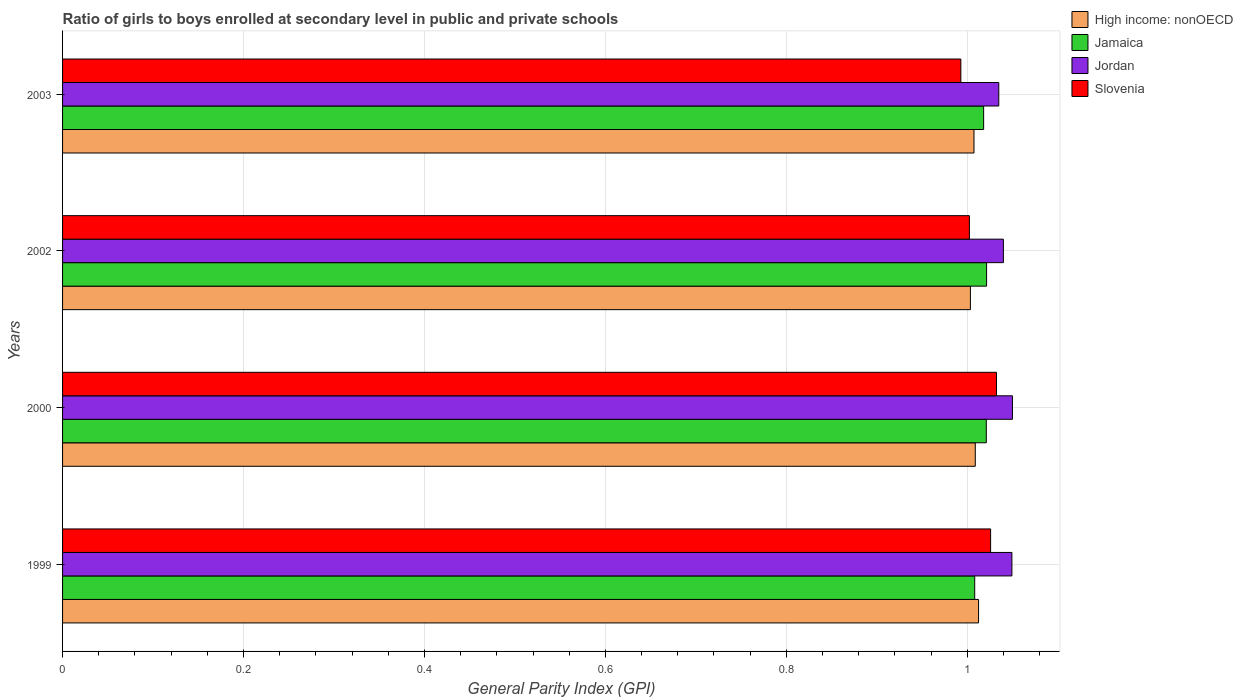How many bars are there on the 3rd tick from the top?
Your answer should be very brief. 4. What is the label of the 3rd group of bars from the top?
Make the answer very short. 2000. What is the general parity index in Slovenia in 1999?
Your answer should be compact. 1.03. Across all years, what is the maximum general parity index in Jamaica?
Ensure brevity in your answer.  1.02. Across all years, what is the minimum general parity index in Jordan?
Your answer should be very brief. 1.03. In which year was the general parity index in Jordan minimum?
Make the answer very short. 2003. What is the total general parity index in Slovenia in the graph?
Offer a very short reply. 4.05. What is the difference between the general parity index in Jamaica in 2002 and that in 2003?
Provide a succinct answer. 0. What is the difference between the general parity index in Jamaica in 1999 and the general parity index in High income: nonOECD in 2002?
Give a very brief answer. 0. What is the average general parity index in High income: nonOECD per year?
Give a very brief answer. 1.01. In the year 2000, what is the difference between the general parity index in High income: nonOECD and general parity index in Jamaica?
Offer a very short reply. -0.01. In how many years, is the general parity index in Jamaica greater than 0.7600000000000001 ?
Make the answer very short. 4. What is the ratio of the general parity index in Jordan in 1999 to that in 2000?
Your answer should be very brief. 1. Is the general parity index in Jordan in 1999 less than that in 2003?
Provide a succinct answer. No. What is the difference between the highest and the second highest general parity index in Jordan?
Provide a succinct answer. 0. What is the difference between the highest and the lowest general parity index in Slovenia?
Provide a succinct answer. 0.04. In how many years, is the general parity index in High income: nonOECD greater than the average general parity index in High income: nonOECD taken over all years?
Your answer should be very brief. 2. Is the sum of the general parity index in Jamaica in 1999 and 2000 greater than the maximum general parity index in High income: nonOECD across all years?
Provide a short and direct response. Yes. Is it the case that in every year, the sum of the general parity index in High income: nonOECD and general parity index in Slovenia is greater than the sum of general parity index in Jordan and general parity index in Jamaica?
Your response must be concise. No. What does the 4th bar from the top in 2002 represents?
Provide a short and direct response. High income: nonOECD. What does the 2nd bar from the bottom in 2002 represents?
Your answer should be compact. Jamaica. Is it the case that in every year, the sum of the general parity index in Jamaica and general parity index in Jordan is greater than the general parity index in High income: nonOECD?
Your answer should be very brief. Yes. Are all the bars in the graph horizontal?
Your answer should be very brief. Yes. How many years are there in the graph?
Give a very brief answer. 4. What is the difference between two consecutive major ticks on the X-axis?
Provide a succinct answer. 0.2. Are the values on the major ticks of X-axis written in scientific E-notation?
Your answer should be compact. No. Does the graph contain any zero values?
Provide a succinct answer. No. Does the graph contain grids?
Offer a very short reply. Yes. Where does the legend appear in the graph?
Offer a terse response. Top right. What is the title of the graph?
Your response must be concise. Ratio of girls to boys enrolled at secondary level in public and private schools. What is the label or title of the X-axis?
Your response must be concise. General Parity Index (GPI). What is the label or title of the Y-axis?
Offer a terse response. Years. What is the General Parity Index (GPI) of High income: nonOECD in 1999?
Offer a very short reply. 1.01. What is the General Parity Index (GPI) in Jamaica in 1999?
Offer a terse response. 1.01. What is the General Parity Index (GPI) of Jordan in 1999?
Keep it short and to the point. 1.05. What is the General Parity Index (GPI) in Slovenia in 1999?
Your answer should be compact. 1.03. What is the General Parity Index (GPI) of High income: nonOECD in 2000?
Provide a succinct answer. 1.01. What is the General Parity Index (GPI) of Jamaica in 2000?
Offer a terse response. 1.02. What is the General Parity Index (GPI) in Jordan in 2000?
Give a very brief answer. 1.05. What is the General Parity Index (GPI) in Slovenia in 2000?
Your answer should be compact. 1.03. What is the General Parity Index (GPI) of High income: nonOECD in 2002?
Your answer should be very brief. 1. What is the General Parity Index (GPI) in Jamaica in 2002?
Your response must be concise. 1.02. What is the General Parity Index (GPI) in Jordan in 2002?
Provide a short and direct response. 1.04. What is the General Parity Index (GPI) of Slovenia in 2002?
Provide a succinct answer. 1. What is the General Parity Index (GPI) of High income: nonOECD in 2003?
Offer a terse response. 1.01. What is the General Parity Index (GPI) of Jamaica in 2003?
Keep it short and to the point. 1.02. What is the General Parity Index (GPI) of Jordan in 2003?
Offer a terse response. 1.03. What is the General Parity Index (GPI) in Slovenia in 2003?
Your answer should be very brief. 0.99. Across all years, what is the maximum General Parity Index (GPI) of High income: nonOECD?
Your response must be concise. 1.01. Across all years, what is the maximum General Parity Index (GPI) of Jamaica?
Offer a terse response. 1.02. Across all years, what is the maximum General Parity Index (GPI) of Jordan?
Keep it short and to the point. 1.05. Across all years, what is the maximum General Parity Index (GPI) in Slovenia?
Your answer should be very brief. 1.03. Across all years, what is the minimum General Parity Index (GPI) in High income: nonOECD?
Provide a succinct answer. 1. Across all years, what is the minimum General Parity Index (GPI) in Jamaica?
Your response must be concise. 1.01. Across all years, what is the minimum General Parity Index (GPI) in Jordan?
Offer a terse response. 1.03. Across all years, what is the minimum General Parity Index (GPI) in Slovenia?
Provide a short and direct response. 0.99. What is the total General Parity Index (GPI) in High income: nonOECD in the graph?
Offer a very short reply. 4.03. What is the total General Parity Index (GPI) of Jamaica in the graph?
Keep it short and to the point. 4.07. What is the total General Parity Index (GPI) in Jordan in the graph?
Your answer should be compact. 4.17. What is the total General Parity Index (GPI) in Slovenia in the graph?
Your answer should be very brief. 4.05. What is the difference between the General Parity Index (GPI) of High income: nonOECD in 1999 and that in 2000?
Your answer should be very brief. 0. What is the difference between the General Parity Index (GPI) in Jamaica in 1999 and that in 2000?
Your response must be concise. -0.01. What is the difference between the General Parity Index (GPI) in Jordan in 1999 and that in 2000?
Your response must be concise. -0. What is the difference between the General Parity Index (GPI) of Slovenia in 1999 and that in 2000?
Make the answer very short. -0.01. What is the difference between the General Parity Index (GPI) of High income: nonOECD in 1999 and that in 2002?
Give a very brief answer. 0.01. What is the difference between the General Parity Index (GPI) of Jamaica in 1999 and that in 2002?
Offer a terse response. -0.01. What is the difference between the General Parity Index (GPI) in Jordan in 1999 and that in 2002?
Your answer should be very brief. 0.01. What is the difference between the General Parity Index (GPI) of Slovenia in 1999 and that in 2002?
Provide a succinct answer. 0.02. What is the difference between the General Parity Index (GPI) of High income: nonOECD in 1999 and that in 2003?
Offer a very short reply. 0.01. What is the difference between the General Parity Index (GPI) in Jamaica in 1999 and that in 2003?
Your answer should be very brief. -0.01. What is the difference between the General Parity Index (GPI) in Jordan in 1999 and that in 2003?
Your response must be concise. 0.01. What is the difference between the General Parity Index (GPI) in Slovenia in 1999 and that in 2003?
Keep it short and to the point. 0.03. What is the difference between the General Parity Index (GPI) in High income: nonOECD in 2000 and that in 2002?
Give a very brief answer. 0.01. What is the difference between the General Parity Index (GPI) of Jamaica in 2000 and that in 2002?
Make the answer very short. -0. What is the difference between the General Parity Index (GPI) of Jordan in 2000 and that in 2002?
Your response must be concise. 0.01. What is the difference between the General Parity Index (GPI) in High income: nonOECD in 2000 and that in 2003?
Your answer should be very brief. 0. What is the difference between the General Parity Index (GPI) in Jamaica in 2000 and that in 2003?
Keep it short and to the point. 0. What is the difference between the General Parity Index (GPI) in Jordan in 2000 and that in 2003?
Keep it short and to the point. 0.02. What is the difference between the General Parity Index (GPI) in Slovenia in 2000 and that in 2003?
Offer a very short reply. 0.04. What is the difference between the General Parity Index (GPI) of High income: nonOECD in 2002 and that in 2003?
Your answer should be very brief. -0. What is the difference between the General Parity Index (GPI) in Jamaica in 2002 and that in 2003?
Your answer should be compact. 0. What is the difference between the General Parity Index (GPI) of Jordan in 2002 and that in 2003?
Keep it short and to the point. 0.01. What is the difference between the General Parity Index (GPI) in Slovenia in 2002 and that in 2003?
Offer a terse response. 0.01. What is the difference between the General Parity Index (GPI) of High income: nonOECD in 1999 and the General Parity Index (GPI) of Jamaica in 2000?
Your answer should be very brief. -0.01. What is the difference between the General Parity Index (GPI) of High income: nonOECD in 1999 and the General Parity Index (GPI) of Jordan in 2000?
Your answer should be very brief. -0.04. What is the difference between the General Parity Index (GPI) of High income: nonOECD in 1999 and the General Parity Index (GPI) of Slovenia in 2000?
Your answer should be very brief. -0.02. What is the difference between the General Parity Index (GPI) in Jamaica in 1999 and the General Parity Index (GPI) in Jordan in 2000?
Keep it short and to the point. -0.04. What is the difference between the General Parity Index (GPI) in Jamaica in 1999 and the General Parity Index (GPI) in Slovenia in 2000?
Your answer should be very brief. -0.02. What is the difference between the General Parity Index (GPI) of Jordan in 1999 and the General Parity Index (GPI) of Slovenia in 2000?
Offer a terse response. 0.02. What is the difference between the General Parity Index (GPI) of High income: nonOECD in 1999 and the General Parity Index (GPI) of Jamaica in 2002?
Offer a very short reply. -0.01. What is the difference between the General Parity Index (GPI) in High income: nonOECD in 1999 and the General Parity Index (GPI) in Jordan in 2002?
Offer a terse response. -0.03. What is the difference between the General Parity Index (GPI) in High income: nonOECD in 1999 and the General Parity Index (GPI) in Slovenia in 2002?
Offer a very short reply. 0.01. What is the difference between the General Parity Index (GPI) of Jamaica in 1999 and the General Parity Index (GPI) of Jordan in 2002?
Offer a terse response. -0.03. What is the difference between the General Parity Index (GPI) of Jamaica in 1999 and the General Parity Index (GPI) of Slovenia in 2002?
Keep it short and to the point. 0.01. What is the difference between the General Parity Index (GPI) in Jordan in 1999 and the General Parity Index (GPI) in Slovenia in 2002?
Your answer should be compact. 0.05. What is the difference between the General Parity Index (GPI) in High income: nonOECD in 1999 and the General Parity Index (GPI) in Jamaica in 2003?
Keep it short and to the point. -0.01. What is the difference between the General Parity Index (GPI) of High income: nonOECD in 1999 and the General Parity Index (GPI) of Jordan in 2003?
Your answer should be very brief. -0.02. What is the difference between the General Parity Index (GPI) in High income: nonOECD in 1999 and the General Parity Index (GPI) in Slovenia in 2003?
Your answer should be very brief. 0.02. What is the difference between the General Parity Index (GPI) of Jamaica in 1999 and the General Parity Index (GPI) of Jordan in 2003?
Your response must be concise. -0.03. What is the difference between the General Parity Index (GPI) in Jamaica in 1999 and the General Parity Index (GPI) in Slovenia in 2003?
Your answer should be compact. 0.02. What is the difference between the General Parity Index (GPI) of Jordan in 1999 and the General Parity Index (GPI) of Slovenia in 2003?
Your answer should be very brief. 0.06. What is the difference between the General Parity Index (GPI) in High income: nonOECD in 2000 and the General Parity Index (GPI) in Jamaica in 2002?
Offer a terse response. -0.01. What is the difference between the General Parity Index (GPI) of High income: nonOECD in 2000 and the General Parity Index (GPI) of Jordan in 2002?
Your response must be concise. -0.03. What is the difference between the General Parity Index (GPI) in High income: nonOECD in 2000 and the General Parity Index (GPI) in Slovenia in 2002?
Your answer should be compact. 0.01. What is the difference between the General Parity Index (GPI) in Jamaica in 2000 and the General Parity Index (GPI) in Jordan in 2002?
Your answer should be compact. -0.02. What is the difference between the General Parity Index (GPI) in Jamaica in 2000 and the General Parity Index (GPI) in Slovenia in 2002?
Your answer should be compact. 0.02. What is the difference between the General Parity Index (GPI) of Jordan in 2000 and the General Parity Index (GPI) of Slovenia in 2002?
Ensure brevity in your answer.  0.05. What is the difference between the General Parity Index (GPI) in High income: nonOECD in 2000 and the General Parity Index (GPI) in Jamaica in 2003?
Offer a terse response. -0.01. What is the difference between the General Parity Index (GPI) of High income: nonOECD in 2000 and the General Parity Index (GPI) of Jordan in 2003?
Provide a succinct answer. -0.03. What is the difference between the General Parity Index (GPI) in High income: nonOECD in 2000 and the General Parity Index (GPI) in Slovenia in 2003?
Make the answer very short. 0.02. What is the difference between the General Parity Index (GPI) of Jamaica in 2000 and the General Parity Index (GPI) of Jordan in 2003?
Your answer should be very brief. -0.01. What is the difference between the General Parity Index (GPI) of Jamaica in 2000 and the General Parity Index (GPI) of Slovenia in 2003?
Provide a succinct answer. 0.03. What is the difference between the General Parity Index (GPI) in Jordan in 2000 and the General Parity Index (GPI) in Slovenia in 2003?
Your answer should be compact. 0.06. What is the difference between the General Parity Index (GPI) in High income: nonOECD in 2002 and the General Parity Index (GPI) in Jamaica in 2003?
Provide a succinct answer. -0.01. What is the difference between the General Parity Index (GPI) in High income: nonOECD in 2002 and the General Parity Index (GPI) in Jordan in 2003?
Your answer should be compact. -0.03. What is the difference between the General Parity Index (GPI) in High income: nonOECD in 2002 and the General Parity Index (GPI) in Slovenia in 2003?
Provide a short and direct response. 0.01. What is the difference between the General Parity Index (GPI) in Jamaica in 2002 and the General Parity Index (GPI) in Jordan in 2003?
Ensure brevity in your answer.  -0.01. What is the difference between the General Parity Index (GPI) of Jamaica in 2002 and the General Parity Index (GPI) of Slovenia in 2003?
Keep it short and to the point. 0.03. What is the difference between the General Parity Index (GPI) of Jordan in 2002 and the General Parity Index (GPI) of Slovenia in 2003?
Your answer should be very brief. 0.05. What is the average General Parity Index (GPI) in Jamaica per year?
Your response must be concise. 1.02. What is the average General Parity Index (GPI) in Jordan per year?
Offer a terse response. 1.04. What is the average General Parity Index (GPI) in Slovenia per year?
Provide a short and direct response. 1.01. In the year 1999, what is the difference between the General Parity Index (GPI) in High income: nonOECD and General Parity Index (GPI) in Jamaica?
Give a very brief answer. 0. In the year 1999, what is the difference between the General Parity Index (GPI) in High income: nonOECD and General Parity Index (GPI) in Jordan?
Offer a very short reply. -0.04. In the year 1999, what is the difference between the General Parity Index (GPI) in High income: nonOECD and General Parity Index (GPI) in Slovenia?
Provide a succinct answer. -0.01. In the year 1999, what is the difference between the General Parity Index (GPI) of Jamaica and General Parity Index (GPI) of Jordan?
Ensure brevity in your answer.  -0.04. In the year 1999, what is the difference between the General Parity Index (GPI) in Jamaica and General Parity Index (GPI) in Slovenia?
Your response must be concise. -0.02. In the year 1999, what is the difference between the General Parity Index (GPI) of Jordan and General Parity Index (GPI) of Slovenia?
Keep it short and to the point. 0.02. In the year 2000, what is the difference between the General Parity Index (GPI) of High income: nonOECD and General Parity Index (GPI) of Jamaica?
Your answer should be compact. -0.01. In the year 2000, what is the difference between the General Parity Index (GPI) of High income: nonOECD and General Parity Index (GPI) of Jordan?
Give a very brief answer. -0.04. In the year 2000, what is the difference between the General Parity Index (GPI) of High income: nonOECD and General Parity Index (GPI) of Slovenia?
Provide a short and direct response. -0.02. In the year 2000, what is the difference between the General Parity Index (GPI) in Jamaica and General Parity Index (GPI) in Jordan?
Your answer should be compact. -0.03. In the year 2000, what is the difference between the General Parity Index (GPI) in Jamaica and General Parity Index (GPI) in Slovenia?
Give a very brief answer. -0.01. In the year 2000, what is the difference between the General Parity Index (GPI) of Jordan and General Parity Index (GPI) of Slovenia?
Offer a terse response. 0.02. In the year 2002, what is the difference between the General Parity Index (GPI) of High income: nonOECD and General Parity Index (GPI) of Jamaica?
Ensure brevity in your answer.  -0.02. In the year 2002, what is the difference between the General Parity Index (GPI) in High income: nonOECD and General Parity Index (GPI) in Jordan?
Your response must be concise. -0.04. In the year 2002, what is the difference between the General Parity Index (GPI) of High income: nonOECD and General Parity Index (GPI) of Slovenia?
Your answer should be compact. 0. In the year 2002, what is the difference between the General Parity Index (GPI) of Jamaica and General Parity Index (GPI) of Jordan?
Provide a succinct answer. -0.02. In the year 2002, what is the difference between the General Parity Index (GPI) of Jamaica and General Parity Index (GPI) of Slovenia?
Keep it short and to the point. 0.02. In the year 2002, what is the difference between the General Parity Index (GPI) in Jordan and General Parity Index (GPI) in Slovenia?
Offer a very short reply. 0.04. In the year 2003, what is the difference between the General Parity Index (GPI) of High income: nonOECD and General Parity Index (GPI) of Jamaica?
Your answer should be very brief. -0.01. In the year 2003, what is the difference between the General Parity Index (GPI) of High income: nonOECD and General Parity Index (GPI) of Jordan?
Provide a succinct answer. -0.03. In the year 2003, what is the difference between the General Parity Index (GPI) in High income: nonOECD and General Parity Index (GPI) in Slovenia?
Keep it short and to the point. 0.01. In the year 2003, what is the difference between the General Parity Index (GPI) of Jamaica and General Parity Index (GPI) of Jordan?
Provide a short and direct response. -0.02. In the year 2003, what is the difference between the General Parity Index (GPI) of Jamaica and General Parity Index (GPI) of Slovenia?
Give a very brief answer. 0.03. In the year 2003, what is the difference between the General Parity Index (GPI) of Jordan and General Parity Index (GPI) of Slovenia?
Provide a short and direct response. 0.04. What is the ratio of the General Parity Index (GPI) in Jamaica in 1999 to that in 2000?
Offer a terse response. 0.99. What is the ratio of the General Parity Index (GPI) in High income: nonOECD in 1999 to that in 2002?
Make the answer very short. 1.01. What is the ratio of the General Parity Index (GPI) in Jamaica in 1999 to that in 2002?
Your response must be concise. 0.99. What is the ratio of the General Parity Index (GPI) in Jordan in 1999 to that in 2002?
Provide a short and direct response. 1.01. What is the ratio of the General Parity Index (GPI) in Slovenia in 1999 to that in 2002?
Keep it short and to the point. 1.02. What is the ratio of the General Parity Index (GPI) of High income: nonOECD in 1999 to that in 2003?
Your answer should be very brief. 1. What is the ratio of the General Parity Index (GPI) of Jamaica in 1999 to that in 2003?
Your response must be concise. 0.99. What is the ratio of the General Parity Index (GPI) of Jordan in 1999 to that in 2003?
Make the answer very short. 1.01. What is the ratio of the General Parity Index (GPI) in Slovenia in 1999 to that in 2003?
Give a very brief answer. 1.03. What is the ratio of the General Parity Index (GPI) of High income: nonOECD in 2000 to that in 2002?
Offer a very short reply. 1.01. What is the ratio of the General Parity Index (GPI) of Jordan in 2000 to that in 2002?
Make the answer very short. 1.01. What is the ratio of the General Parity Index (GPI) of Slovenia in 2000 to that in 2002?
Offer a very short reply. 1.03. What is the ratio of the General Parity Index (GPI) in High income: nonOECD in 2000 to that in 2003?
Give a very brief answer. 1. What is the ratio of the General Parity Index (GPI) of Jamaica in 2000 to that in 2003?
Provide a short and direct response. 1. What is the ratio of the General Parity Index (GPI) of Jordan in 2000 to that in 2003?
Your response must be concise. 1.01. What is the ratio of the General Parity Index (GPI) in Slovenia in 2000 to that in 2003?
Your response must be concise. 1.04. What is the ratio of the General Parity Index (GPI) of Slovenia in 2002 to that in 2003?
Keep it short and to the point. 1.01. What is the difference between the highest and the second highest General Parity Index (GPI) in High income: nonOECD?
Offer a terse response. 0. What is the difference between the highest and the second highest General Parity Index (GPI) in Jordan?
Keep it short and to the point. 0. What is the difference between the highest and the second highest General Parity Index (GPI) of Slovenia?
Your answer should be very brief. 0.01. What is the difference between the highest and the lowest General Parity Index (GPI) in High income: nonOECD?
Ensure brevity in your answer.  0.01. What is the difference between the highest and the lowest General Parity Index (GPI) in Jamaica?
Make the answer very short. 0.01. What is the difference between the highest and the lowest General Parity Index (GPI) in Jordan?
Provide a short and direct response. 0.02. What is the difference between the highest and the lowest General Parity Index (GPI) in Slovenia?
Make the answer very short. 0.04. 